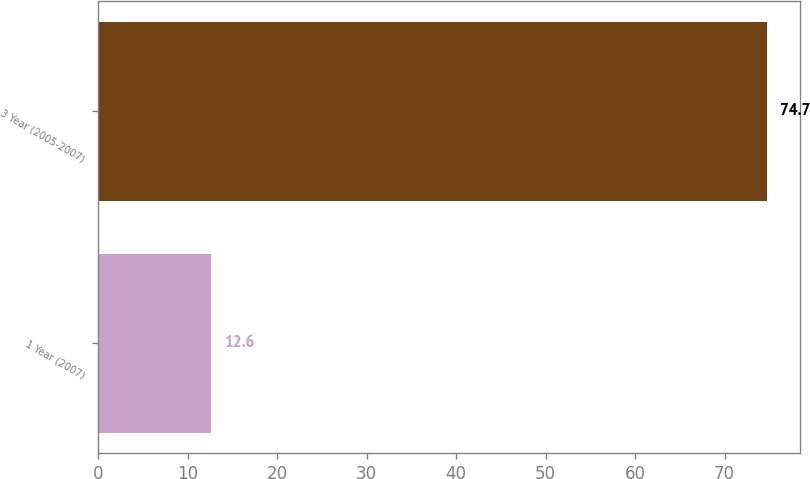Convert chart. <chart><loc_0><loc_0><loc_500><loc_500><bar_chart><fcel>1 Year (2007)<fcel>3 Year (2005-2007)<nl><fcel>12.6<fcel>74.7<nl></chart> 